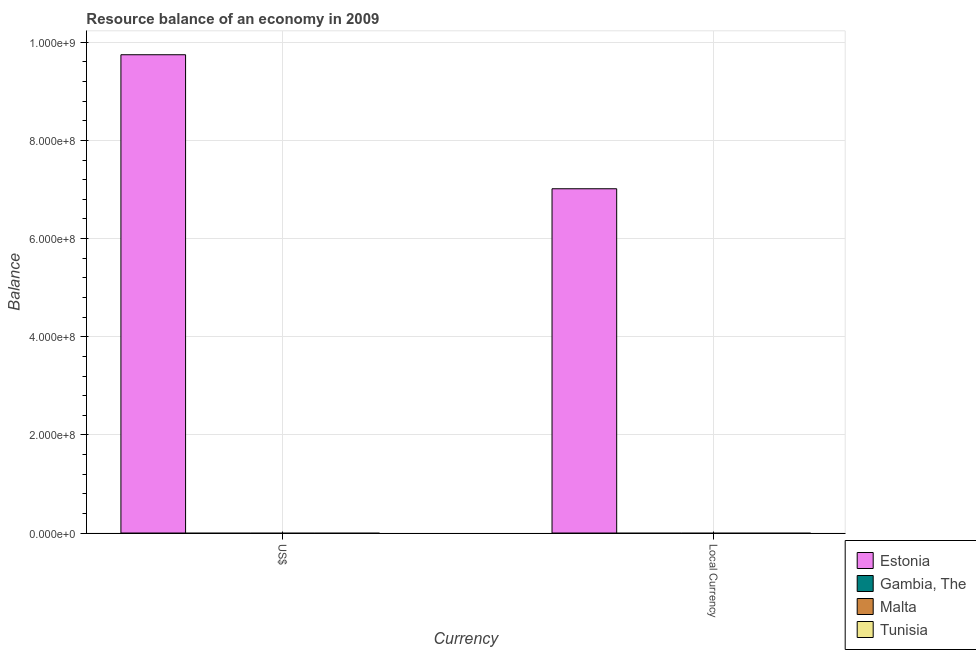How many different coloured bars are there?
Offer a very short reply. 1. Are the number of bars per tick equal to the number of legend labels?
Provide a succinct answer. No. Are the number of bars on each tick of the X-axis equal?
Offer a terse response. Yes. What is the label of the 2nd group of bars from the left?
Your answer should be compact. Local Currency. Across all countries, what is the maximum resource balance in us$?
Make the answer very short. 9.75e+08. In which country was the resource balance in us$ maximum?
Provide a succinct answer. Estonia. What is the total resource balance in us$ in the graph?
Your response must be concise. 9.75e+08. What is the difference between the resource balance in us$ in Malta and the resource balance in constant us$ in Gambia, The?
Your response must be concise. 0. What is the average resource balance in us$ per country?
Offer a very short reply. 2.44e+08. What is the difference between the resource balance in constant us$ and resource balance in us$ in Estonia?
Your response must be concise. -2.73e+08. In how many countries, is the resource balance in us$ greater than 440000000 units?
Provide a short and direct response. 1. How many bars are there?
Keep it short and to the point. 2. Are all the bars in the graph horizontal?
Your response must be concise. No. How many countries are there in the graph?
Provide a short and direct response. 4. What is the difference between two consecutive major ticks on the Y-axis?
Offer a very short reply. 2.00e+08. Does the graph contain grids?
Keep it short and to the point. Yes. What is the title of the graph?
Keep it short and to the point. Resource balance of an economy in 2009. What is the label or title of the X-axis?
Your response must be concise. Currency. What is the label or title of the Y-axis?
Make the answer very short. Balance. What is the Balance in Estonia in US$?
Your answer should be compact. 9.75e+08. What is the Balance in Gambia, The in US$?
Provide a succinct answer. 0. What is the Balance in Tunisia in US$?
Your answer should be compact. 0. What is the Balance in Estonia in Local Currency?
Give a very brief answer. 7.02e+08. What is the Balance in Gambia, The in Local Currency?
Your answer should be very brief. 0. What is the Balance of Malta in Local Currency?
Offer a terse response. 0. What is the Balance in Tunisia in Local Currency?
Offer a terse response. 0. Across all Currency, what is the maximum Balance of Estonia?
Keep it short and to the point. 9.75e+08. Across all Currency, what is the minimum Balance of Estonia?
Keep it short and to the point. 7.02e+08. What is the total Balance of Estonia in the graph?
Offer a terse response. 1.68e+09. What is the total Balance of Gambia, The in the graph?
Ensure brevity in your answer.  0. What is the difference between the Balance of Estonia in US$ and that in Local Currency?
Keep it short and to the point. 2.73e+08. What is the average Balance of Estonia per Currency?
Your answer should be very brief. 8.38e+08. What is the average Balance in Gambia, The per Currency?
Ensure brevity in your answer.  0. What is the average Balance of Tunisia per Currency?
Keep it short and to the point. 0. What is the ratio of the Balance in Estonia in US$ to that in Local Currency?
Keep it short and to the point. 1.39. What is the difference between the highest and the second highest Balance of Estonia?
Ensure brevity in your answer.  2.73e+08. What is the difference between the highest and the lowest Balance of Estonia?
Make the answer very short. 2.73e+08. 